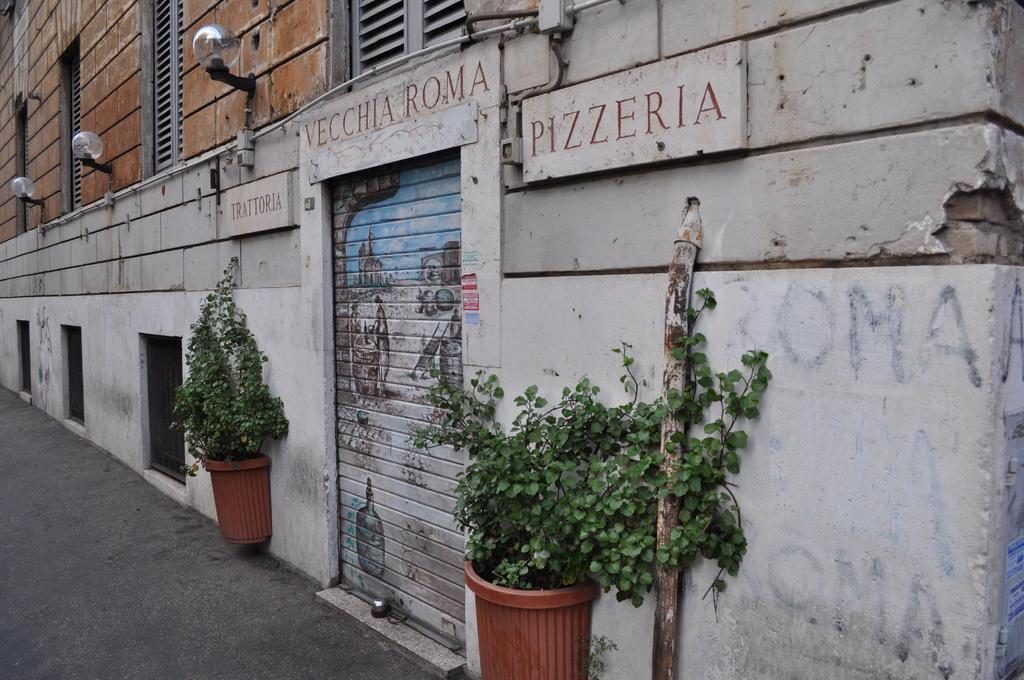In one or two sentences, can you explain what this image depicts? In this picture there are some plant pots in the front. Beside there is a roller shutter shop. On the top we can see the brown color wall with the hanging lights. 